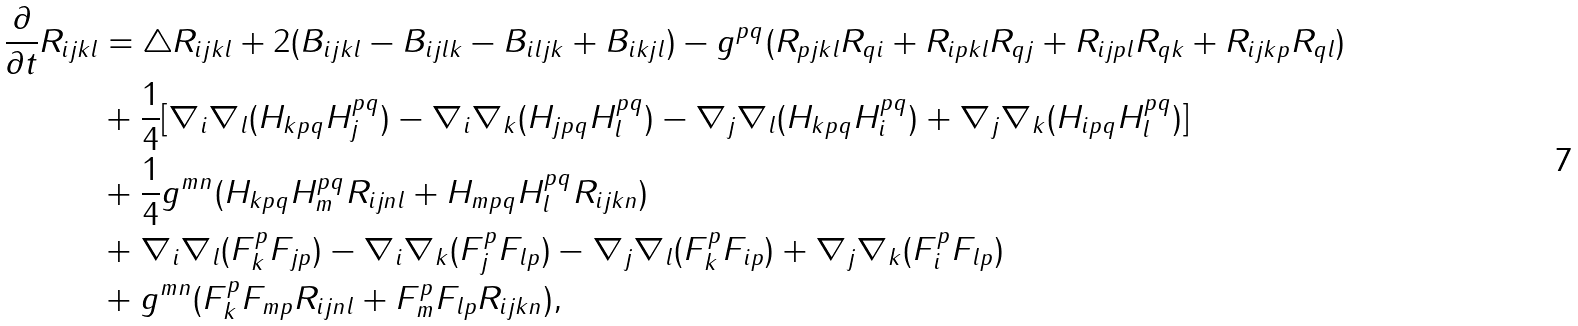Convert formula to latex. <formula><loc_0><loc_0><loc_500><loc_500>\frac { \partial } { \partial t } R _ { i j k l } & = \triangle R _ { i j k l } + 2 ( B _ { i j k l } - B _ { i j l k } - B _ { i l j k } + B _ { i k j l } ) - g ^ { p q } ( R _ { p j k l } R _ { q i } + R _ { i p k l } R _ { q j } + R _ { i j p l } R _ { q k } + R _ { i j k p } R _ { q l } ) \\ & + \frac { 1 } { 4 } [ \nabla _ { i } \nabla _ { l } ( H _ { k p q } H _ { j } ^ { p q } ) - \nabla _ { i } \nabla _ { k } ( H _ { j p q } H _ { l } ^ { p q } ) - \nabla _ { j } \nabla _ { l } ( H _ { k p q } H _ { i } ^ { p q } ) + \nabla _ { j } \nabla _ { k } ( H _ { i p q } H _ { l } ^ { p q } ) ] \\ & + \frac { 1 } { 4 } g ^ { m n } ( H _ { k p q } H _ { m } ^ { p q } R _ { i j n l } + H _ { m p q } H _ { l } ^ { p q } R _ { i j k n } ) \\ & + \nabla _ { i } \nabla _ { l } ( F _ { k } ^ { p } F _ { j p } ) - \nabla _ { i } \nabla _ { k } ( F _ { j } ^ { p } F _ { l p } ) - \nabla _ { j } \nabla _ { l } ( F _ { k } ^ { p } F _ { i p } ) + \nabla _ { j } \nabla _ { k } ( F _ { i } ^ { p } F _ { l p } ) \\ & + g ^ { m n } ( F _ { k } ^ { p } F _ { m p } R _ { i j n l } + F _ { m } ^ { p } F _ { l p } R _ { i j k n } ) , \\</formula> 